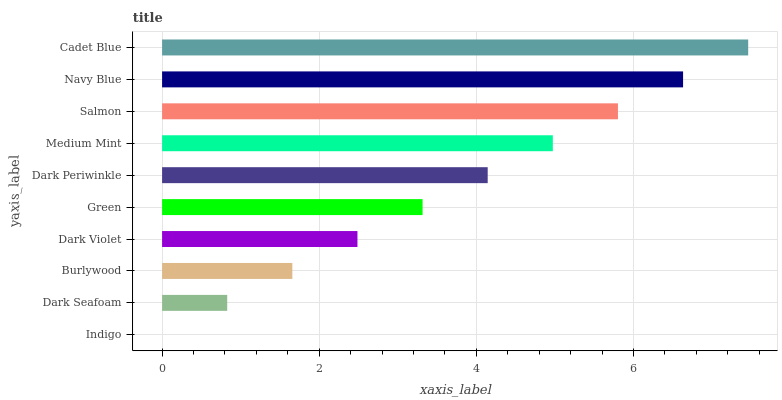Is Indigo the minimum?
Answer yes or no. Yes. Is Cadet Blue the maximum?
Answer yes or no. Yes. Is Dark Seafoam the minimum?
Answer yes or no. No. Is Dark Seafoam the maximum?
Answer yes or no. No. Is Dark Seafoam greater than Indigo?
Answer yes or no. Yes. Is Indigo less than Dark Seafoam?
Answer yes or no. Yes. Is Indigo greater than Dark Seafoam?
Answer yes or no. No. Is Dark Seafoam less than Indigo?
Answer yes or no. No. Is Dark Periwinkle the high median?
Answer yes or no. Yes. Is Green the low median?
Answer yes or no. Yes. Is Burlywood the high median?
Answer yes or no. No. Is Navy Blue the low median?
Answer yes or no. No. 